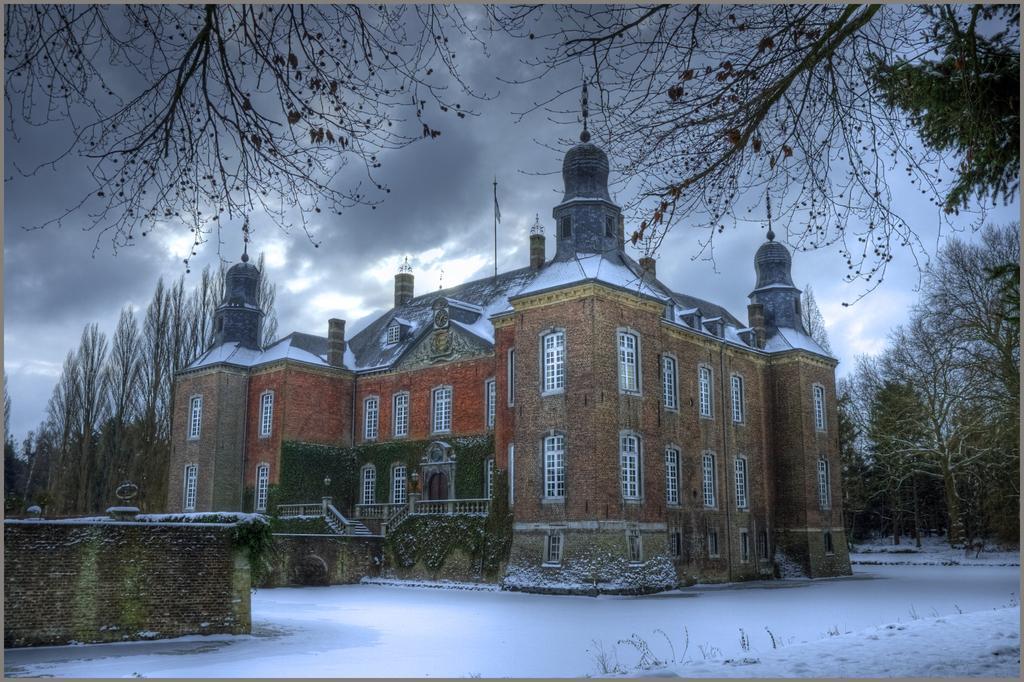Can you describe this image briefly? In this image we can see a building with windows, steps and railings. On the ground there is snow. Also there are walls. On the sides of the building there are trees. In the background there is sky with clouds. At the top we can see branches of trees. 